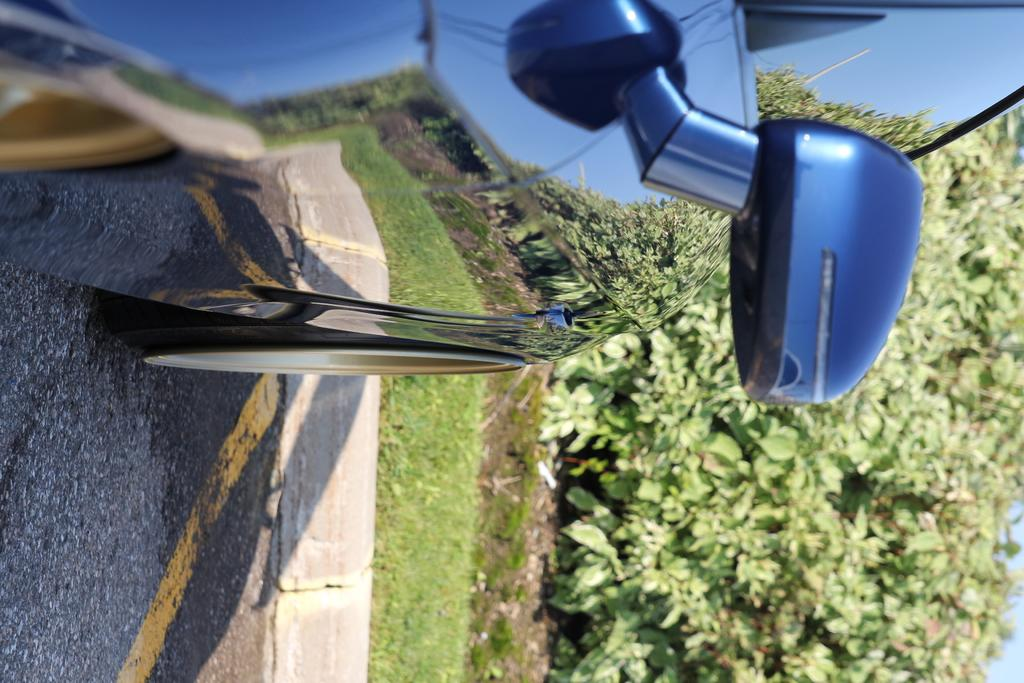What is the main subject of the image? There is a car on the road in the image. What else can be seen in the image besides the car? Plants are visible in the image. What is unique about the car's appearance in the image? The reflection of plants, poles, and the sky is visible on the car. Where is the cushion placed in the image? There is no cushion present in the image. Can you tell me how many times the person in the image runs around the car? There is no person running around the car in the image. 